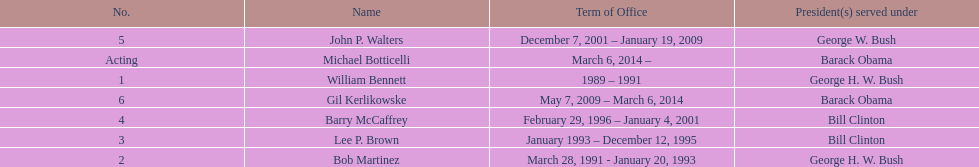How many directors served more than 3 years? 3. 